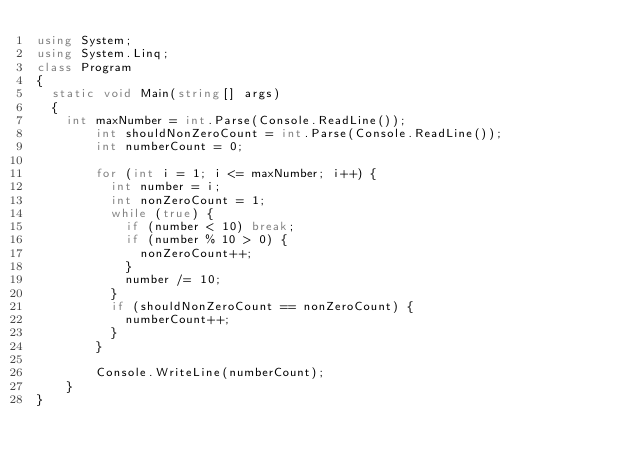<code> <loc_0><loc_0><loc_500><loc_500><_C#_>using System;
using System.Linq;
class Program
{
	static void Main(string[] args)
	{
		int maxNumber = int.Parse(Console.ReadLine());
        int shouldNonZeroCount = int.Parse(Console.ReadLine());
        int numberCount = 0;
      
        for (int i = 1; i <= maxNumber; i++) {
          int number = i;
          int nonZeroCount = 1;
          while (true) {
            if (number < 10) break;
            if (number % 10 > 0) {
              nonZeroCount++;
            }
            number /= 10;
          }
          if (shouldNonZeroCount == nonZeroCount) {
            numberCount++;
          }
        }
      
        Console.WriteLine(numberCount);
    }
}</code> 